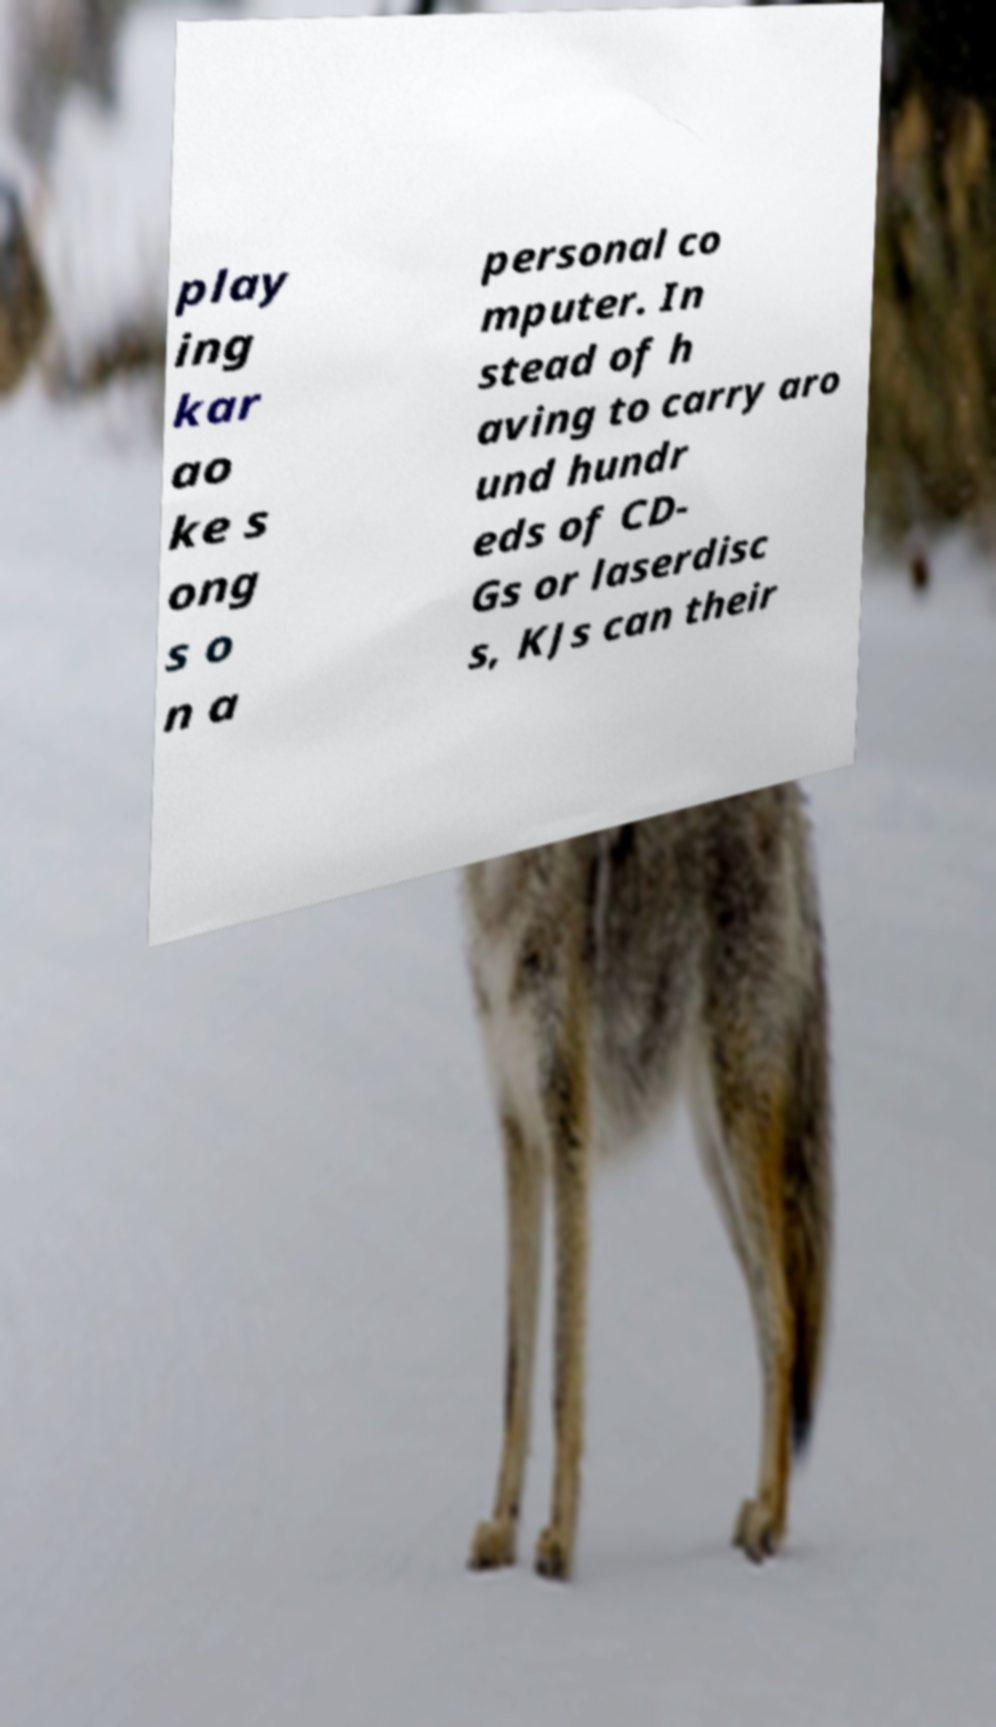What messages or text are displayed in this image? I need them in a readable, typed format. play ing kar ao ke s ong s o n a personal co mputer. In stead of h aving to carry aro und hundr eds of CD- Gs or laserdisc s, KJs can their 